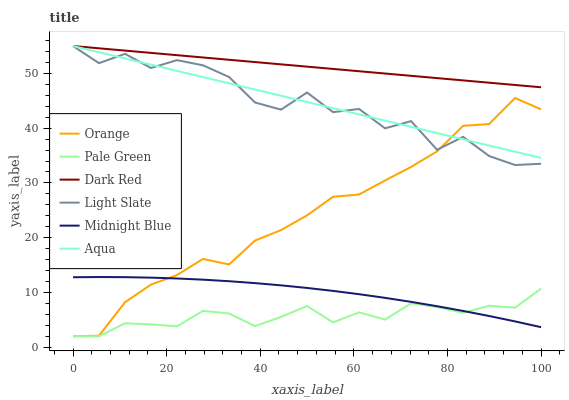Does Pale Green have the minimum area under the curve?
Answer yes or no. Yes. Does Dark Red have the maximum area under the curve?
Answer yes or no. Yes. Does Light Slate have the minimum area under the curve?
Answer yes or no. No. Does Light Slate have the maximum area under the curve?
Answer yes or no. No. Is Aqua the smoothest?
Answer yes or no. Yes. Is Light Slate the roughest?
Answer yes or no. Yes. Is Dark Red the smoothest?
Answer yes or no. No. Is Dark Red the roughest?
Answer yes or no. No. Does Pale Green have the lowest value?
Answer yes or no. Yes. Does Light Slate have the lowest value?
Answer yes or no. No. Does Aqua have the highest value?
Answer yes or no. Yes. Does Pale Green have the highest value?
Answer yes or no. No. Is Midnight Blue less than Dark Red?
Answer yes or no. Yes. Is Aqua greater than Midnight Blue?
Answer yes or no. Yes. Does Orange intersect Aqua?
Answer yes or no. Yes. Is Orange less than Aqua?
Answer yes or no. No. Is Orange greater than Aqua?
Answer yes or no. No. Does Midnight Blue intersect Dark Red?
Answer yes or no. No. 